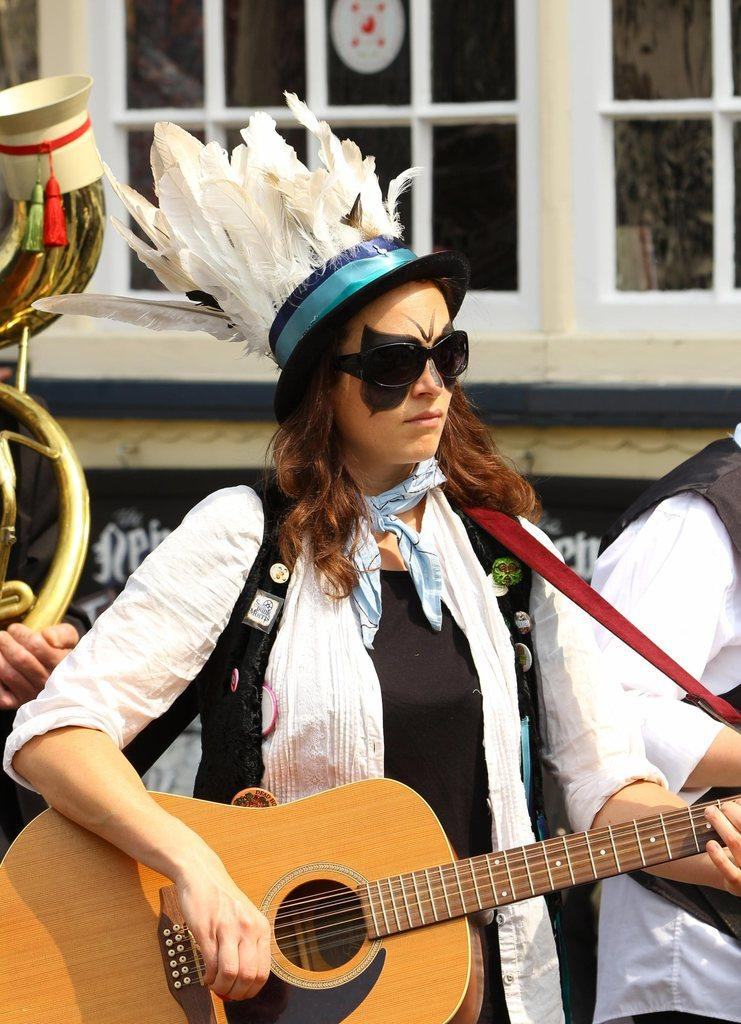Who is the main subject in the image? There is a woman in the middle of the image. What is the woman wearing? The woman is wearing a white dress. Can you describe the woman's hair? The woman has short hair. What is the woman doing in the image? The woman is playing a guitar. Who else is present in the image? There is a person on the right side of the image. What can be seen in the background of the image? There is a window and a building in the background of the image. How many pies does the woman have on her feet in the image? There are no pies present in the image, and the woman's feet are not visible. 